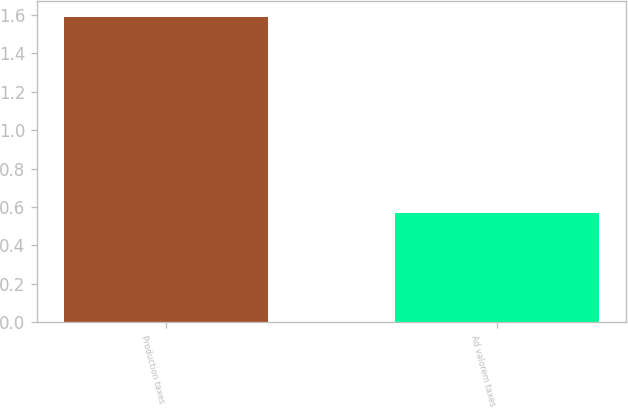<chart> <loc_0><loc_0><loc_500><loc_500><bar_chart><fcel>Production taxes<fcel>Ad valorem taxes<nl><fcel>1.59<fcel>0.57<nl></chart> 